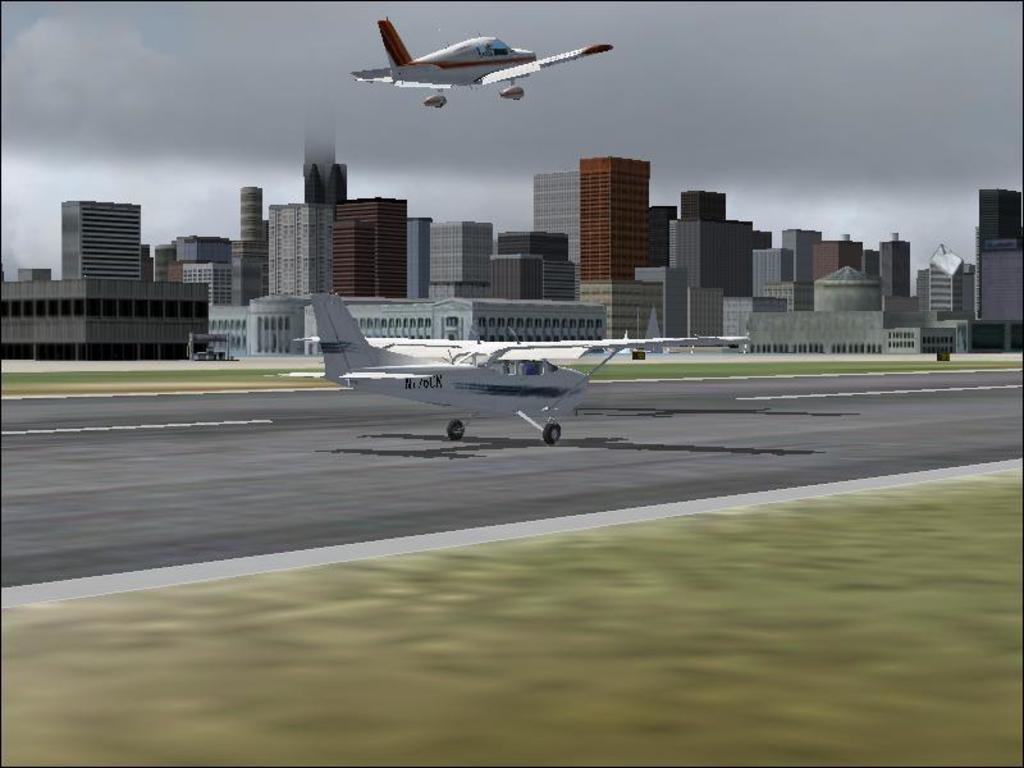In one or two sentences, can you explain what this image depicts? This is an animated image. In the background of the image there are buildings. There are two aeroplanes. At the bottom of the image there is road. There is grass. At the top of the image there is sky. 